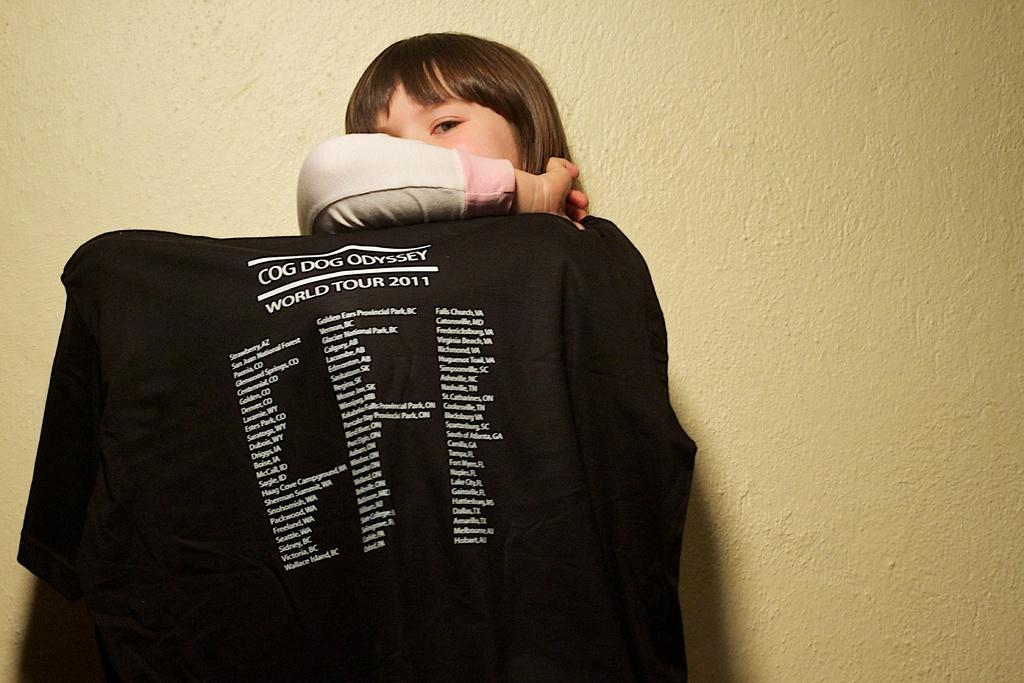Describe this image in one or two sentences. In the picture we can see a girl standing near the wall and she is covering her face with a hand and a black colored cloth with some information on it. 